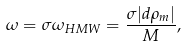<formula> <loc_0><loc_0><loc_500><loc_500>\omega = \sigma \omega _ { H M W } = \frac { \sigma | d \rho _ { m } | } { M } ,</formula> 